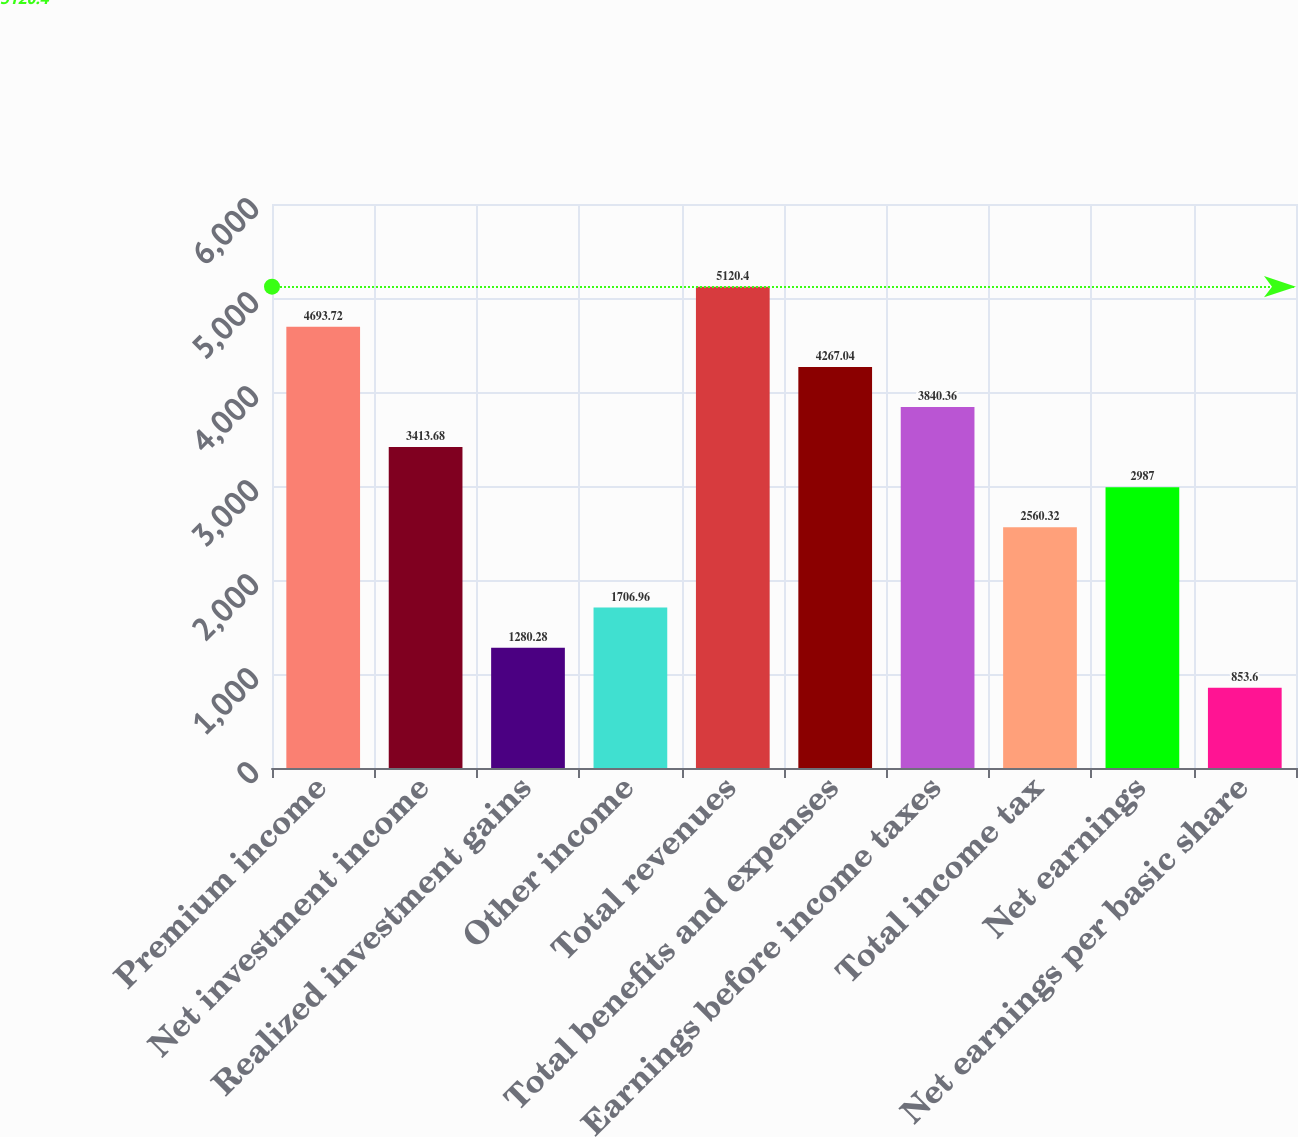<chart> <loc_0><loc_0><loc_500><loc_500><bar_chart><fcel>Premium income<fcel>Net investment income<fcel>Realized investment gains<fcel>Other income<fcel>Total revenues<fcel>Total benefits and expenses<fcel>Earnings before income taxes<fcel>Total income tax<fcel>Net earnings<fcel>Net earnings per basic share<nl><fcel>4693.72<fcel>3413.68<fcel>1280.28<fcel>1706.96<fcel>5120.4<fcel>4267.04<fcel>3840.36<fcel>2560.32<fcel>2987<fcel>853.6<nl></chart> 